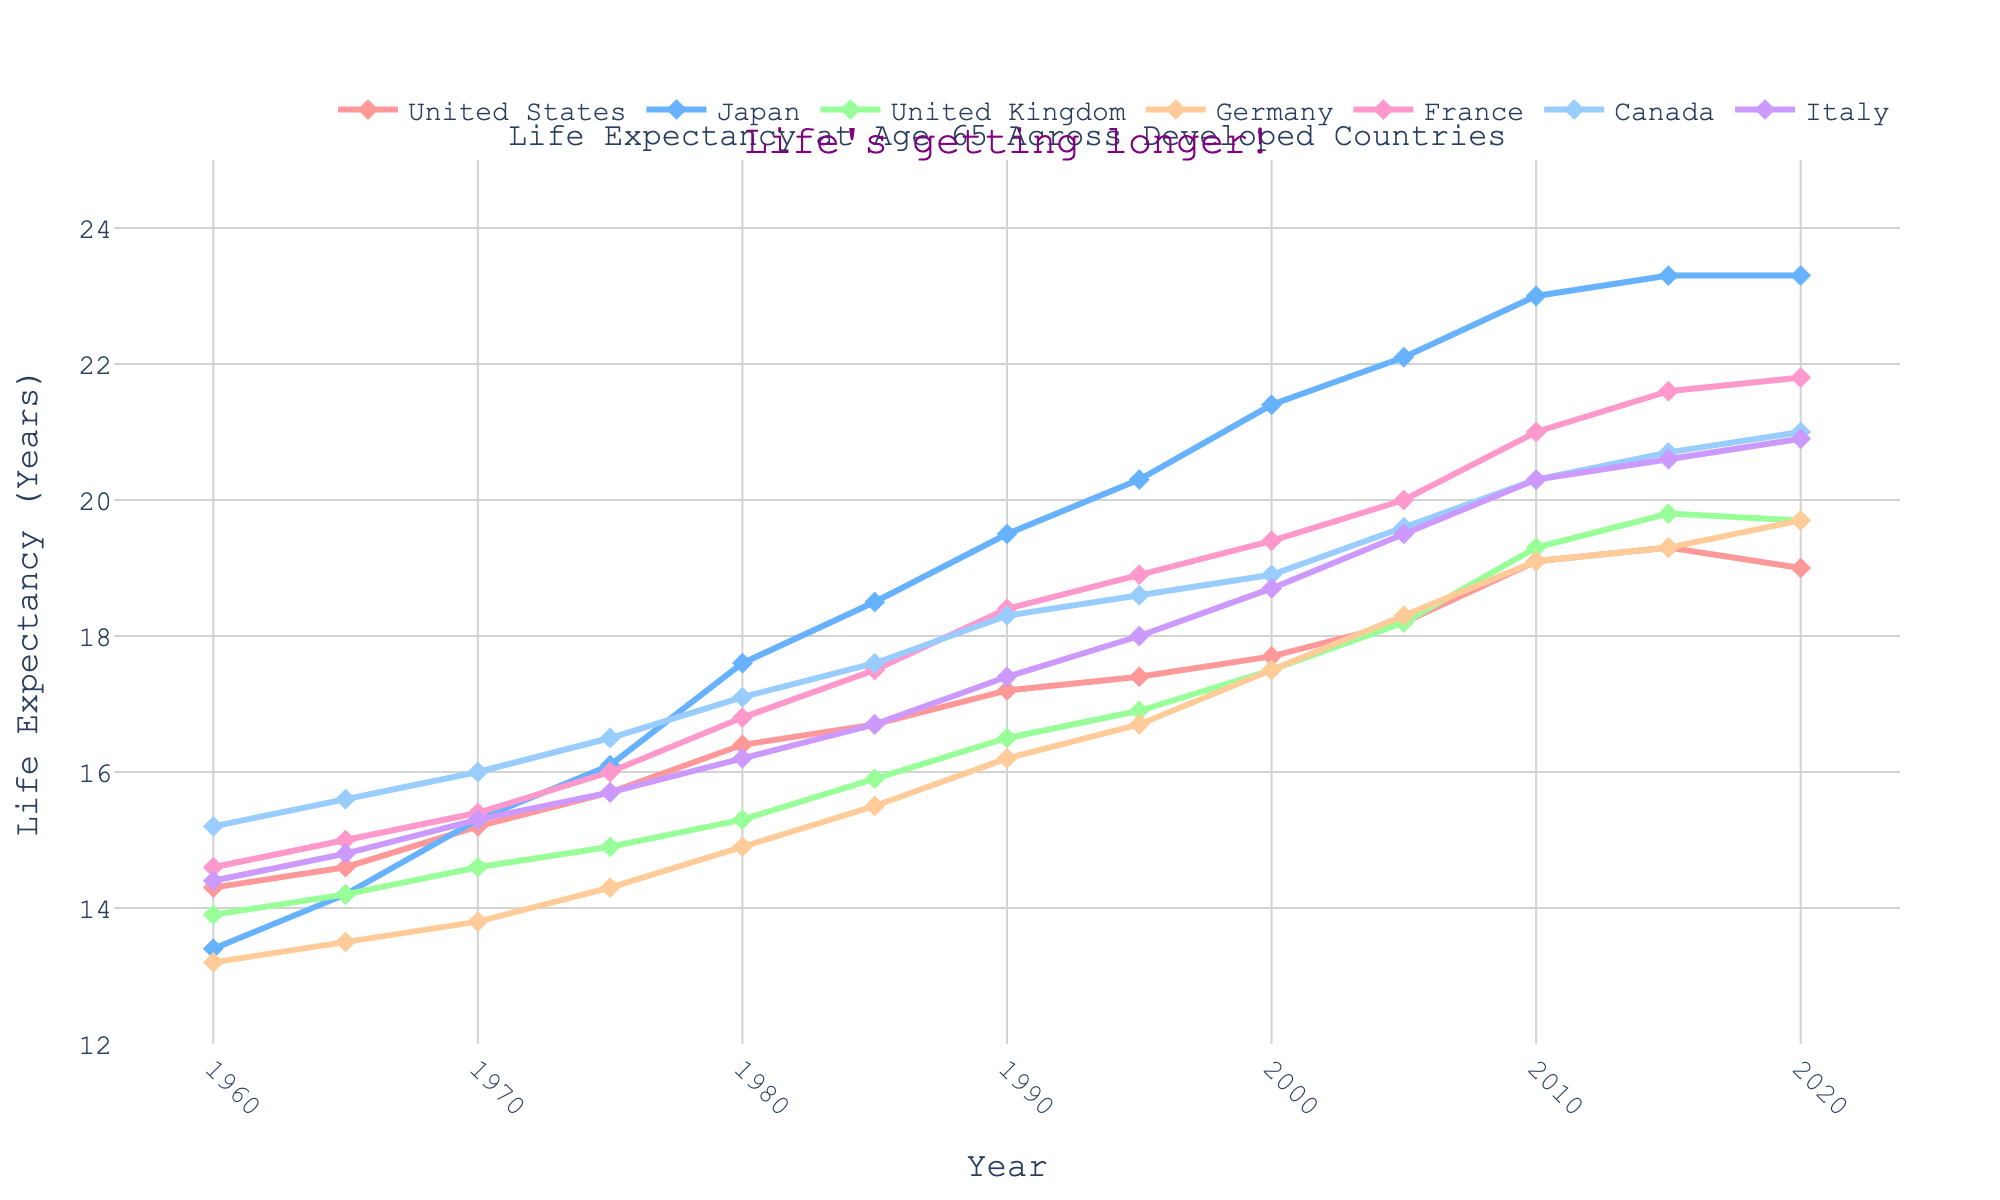Which country had the highest life expectancy in 1980? To find this, look at the y-axis values for each country in 1980. The highest value among them is for Japan.
Answer: Japan What was the difference in life expectancy between the United States and Canada in 2010? Check the y-axis values for both the United States and Canada in 2010. Subtract the United States value from the Canada value: 20.3 - 19.1 = 1.2.
Answer: 1.2 years Which country showed the greatest increase in life expectancy from 1960 to 2020? Calculate the increase for each country by subtracting their 1960 value from their 2020 value. The country with the highest difference is Japan (23.3 - 13.4 = 9.9).
Answer: Japan How did the life expectancy in Italy compare to that in France in 1995? Look at the y-axis values for Italy and France in 1995. Both values are nearly the same, 18.0 for Italy and 18.9 for France.
Answer: France > Italy Which two countries had almost equal life expectancy in 2005? Look at the y-axis values for each country in 2005. Both the United Kingdom and Germany had almost equal life expectancy values, at 18.2 and 18.3 respectively.
Answer: United Kingdom and Germany What has been the trend for Japan in terms of life expectancy from 1960 to 2020? Japan shows a steady increase in life expectancy from 1960 (13.4) to 2020 (23.3), indicating a significant positive trend.
Answer: Steady increase By how many years did the life expectancy in Germany improve from 1960 to 1995? Subtract the 1960 value for Germany from the 1995 value: 16.7 - 13.2 = 3.5 years.
Answer: 3.5 years Between 1990 and 2000, which country had the smallest increase in life expectancy? Calculate the increase for each country between 1990 to 2000, and find the smallest difference. The United Kingdom had the smallest increase (17.5 - 16.5 = 1).
Answer: United Kingdom Which country experienced a decline in life expectancy from 2015 to 2020? Check if any country's life expectancy decreased between 2015 and 2020. The United States experienced a decline (19.3 to 19.0).
Answer: United States 